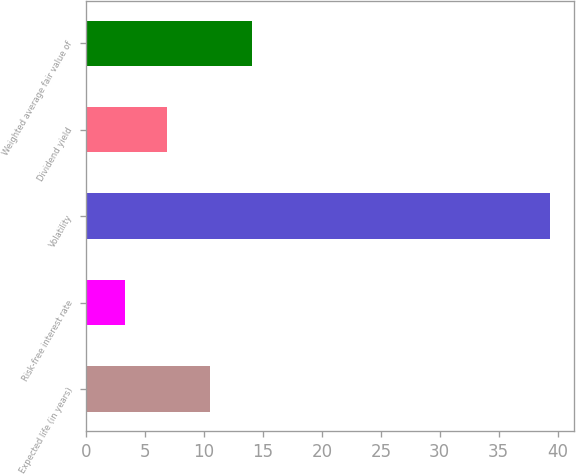<chart> <loc_0><loc_0><loc_500><loc_500><bar_chart><fcel>Expected life (in years)<fcel>Risk-free interest rate<fcel>Volatility<fcel>Dividend yield<fcel>Weighted average fair value of<nl><fcel>10.49<fcel>3.27<fcel>39.4<fcel>6.88<fcel>14.1<nl></chart> 